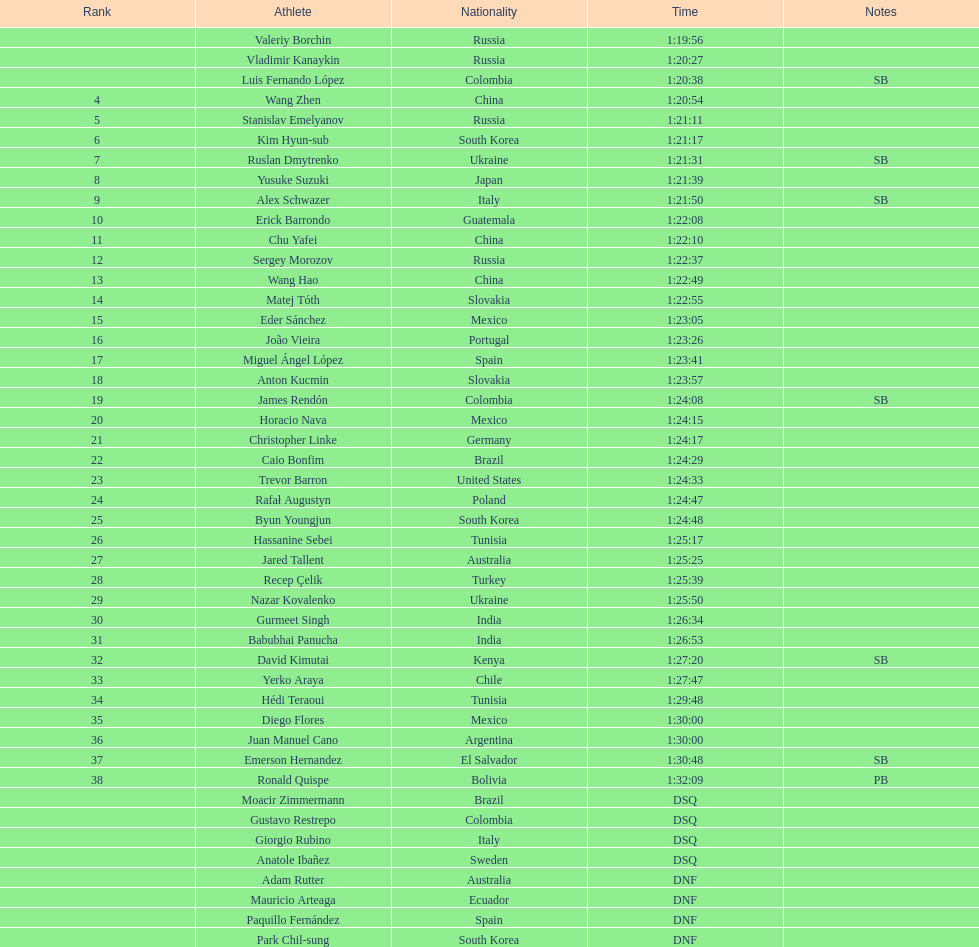How many russians secured a minimum of 3rd place in the 20km walk event? 2. Could you parse the entire table? {'header': ['Rank', 'Athlete', 'Nationality', 'Time', 'Notes'], 'rows': [['', 'Valeriy Borchin', 'Russia', '1:19:56', ''], ['', 'Vladimir Kanaykin', 'Russia', '1:20:27', ''], ['', 'Luis Fernando López', 'Colombia', '1:20:38', 'SB'], ['4', 'Wang Zhen', 'China', '1:20:54', ''], ['5', 'Stanislav Emelyanov', 'Russia', '1:21:11', ''], ['6', 'Kim Hyun-sub', 'South Korea', '1:21:17', ''], ['7', 'Ruslan Dmytrenko', 'Ukraine', '1:21:31', 'SB'], ['8', 'Yusuke Suzuki', 'Japan', '1:21:39', ''], ['9', 'Alex Schwazer', 'Italy', '1:21:50', 'SB'], ['10', 'Erick Barrondo', 'Guatemala', '1:22:08', ''], ['11', 'Chu Yafei', 'China', '1:22:10', ''], ['12', 'Sergey Morozov', 'Russia', '1:22:37', ''], ['13', 'Wang Hao', 'China', '1:22:49', ''], ['14', 'Matej Tóth', 'Slovakia', '1:22:55', ''], ['15', 'Eder Sánchez', 'Mexico', '1:23:05', ''], ['16', 'João Vieira', 'Portugal', '1:23:26', ''], ['17', 'Miguel Ángel López', 'Spain', '1:23:41', ''], ['18', 'Anton Kucmin', 'Slovakia', '1:23:57', ''], ['19', 'James Rendón', 'Colombia', '1:24:08', 'SB'], ['20', 'Horacio Nava', 'Mexico', '1:24:15', ''], ['21', 'Christopher Linke', 'Germany', '1:24:17', ''], ['22', 'Caio Bonfim', 'Brazil', '1:24:29', ''], ['23', 'Trevor Barron', 'United States', '1:24:33', ''], ['24', 'Rafał Augustyn', 'Poland', '1:24:47', ''], ['25', 'Byun Youngjun', 'South Korea', '1:24:48', ''], ['26', 'Hassanine Sebei', 'Tunisia', '1:25:17', ''], ['27', 'Jared Tallent', 'Australia', '1:25:25', ''], ['28', 'Recep Çelik', 'Turkey', '1:25:39', ''], ['29', 'Nazar Kovalenko', 'Ukraine', '1:25:50', ''], ['30', 'Gurmeet Singh', 'India', '1:26:34', ''], ['31', 'Babubhai Panucha', 'India', '1:26:53', ''], ['32', 'David Kimutai', 'Kenya', '1:27:20', 'SB'], ['33', 'Yerko Araya', 'Chile', '1:27:47', ''], ['34', 'Hédi Teraoui', 'Tunisia', '1:29:48', ''], ['35', 'Diego Flores', 'Mexico', '1:30:00', ''], ['36', 'Juan Manuel Cano', 'Argentina', '1:30:00', ''], ['37', 'Emerson Hernandez', 'El Salvador', '1:30:48', 'SB'], ['38', 'Ronald Quispe', 'Bolivia', '1:32:09', 'PB'], ['', 'Moacir Zimmermann', 'Brazil', 'DSQ', ''], ['', 'Gustavo Restrepo', 'Colombia', 'DSQ', ''], ['', 'Giorgio Rubino', 'Italy', 'DSQ', ''], ['', 'Anatole Ibañez', 'Sweden', 'DSQ', ''], ['', 'Adam Rutter', 'Australia', 'DNF', ''], ['', 'Mauricio Arteaga', 'Ecuador', 'DNF', ''], ['', 'Paquillo Fernández', 'Spain', 'DNF', ''], ['', 'Park Chil-sung', 'South Korea', 'DNF', '']]} 